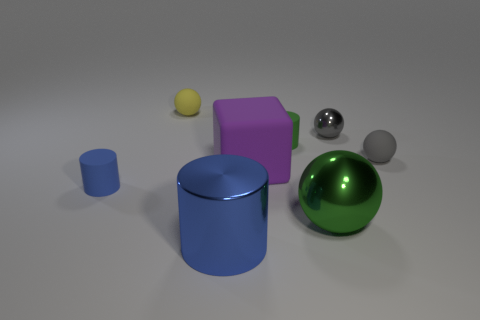There is a tiny matte cylinder in front of the small gray matte object; is it the same color as the rubber cube? no 